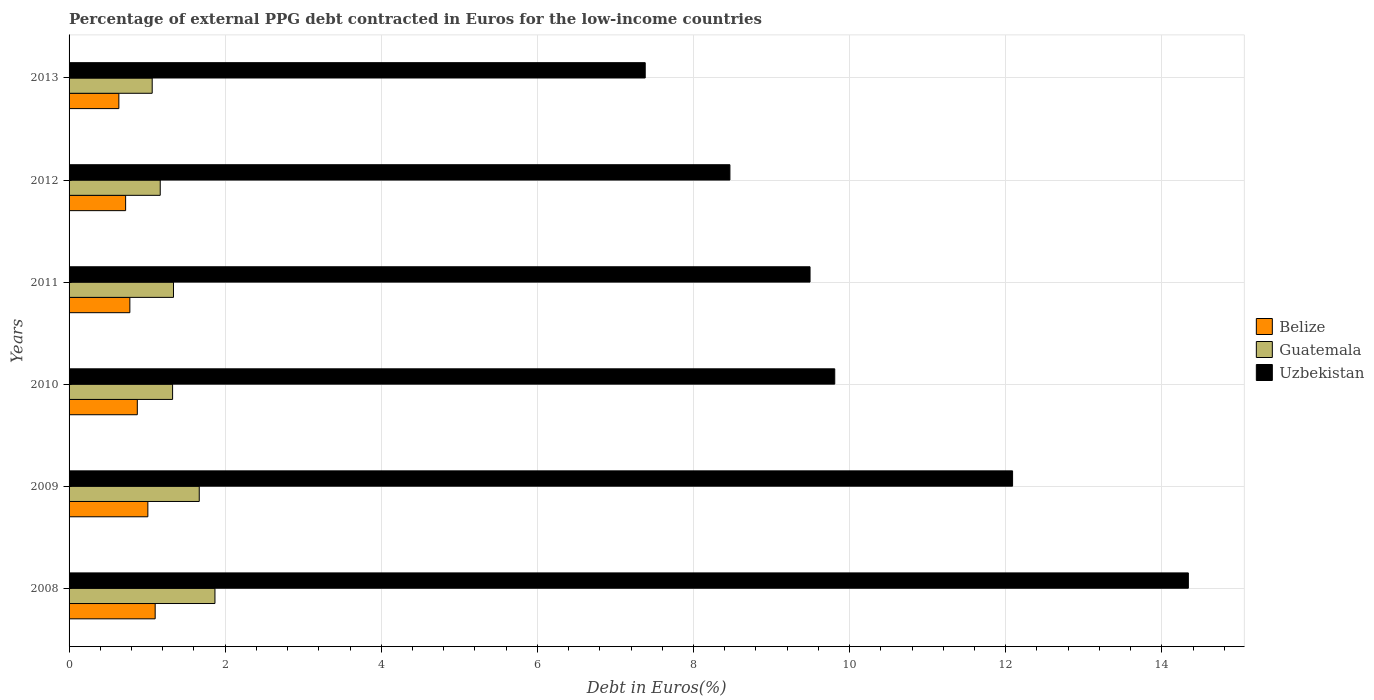How many different coloured bars are there?
Your answer should be compact. 3. Are the number of bars per tick equal to the number of legend labels?
Offer a terse response. Yes. Are the number of bars on each tick of the Y-axis equal?
Keep it short and to the point. Yes. How many bars are there on the 5th tick from the bottom?
Your answer should be compact. 3. In how many cases, is the number of bars for a given year not equal to the number of legend labels?
Ensure brevity in your answer.  0. What is the percentage of external PPG debt contracted in Euros in Guatemala in 2011?
Offer a very short reply. 1.34. Across all years, what is the maximum percentage of external PPG debt contracted in Euros in Guatemala?
Give a very brief answer. 1.87. Across all years, what is the minimum percentage of external PPG debt contracted in Euros in Guatemala?
Provide a short and direct response. 1.07. In which year was the percentage of external PPG debt contracted in Euros in Uzbekistan maximum?
Your answer should be very brief. 2008. In which year was the percentage of external PPG debt contracted in Euros in Belize minimum?
Your response must be concise. 2013. What is the total percentage of external PPG debt contracted in Euros in Belize in the graph?
Your response must be concise. 5.13. What is the difference between the percentage of external PPG debt contracted in Euros in Uzbekistan in 2011 and that in 2012?
Provide a succinct answer. 1.03. What is the difference between the percentage of external PPG debt contracted in Euros in Guatemala in 2008 and the percentage of external PPG debt contracted in Euros in Uzbekistan in 2013?
Offer a very short reply. -5.51. What is the average percentage of external PPG debt contracted in Euros in Belize per year?
Your answer should be very brief. 0.85. In the year 2012, what is the difference between the percentage of external PPG debt contracted in Euros in Guatemala and percentage of external PPG debt contracted in Euros in Belize?
Your answer should be compact. 0.44. What is the ratio of the percentage of external PPG debt contracted in Euros in Uzbekistan in 2012 to that in 2013?
Your answer should be compact. 1.15. What is the difference between the highest and the second highest percentage of external PPG debt contracted in Euros in Uzbekistan?
Offer a very short reply. 2.25. What is the difference between the highest and the lowest percentage of external PPG debt contracted in Euros in Guatemala?
Your answer should be compact. 0.8. What does the 1st bar from the top in 2008 represents?
Offer a terse response. Uzbekistan. What does the 2nd bar from the bottom in 2010 represents?
Your response must be concise. Guatemala. Is it the case that in every year, the sum of the percentage of external PPG debt contracted in Euros in Belize and percentage of external PPG debt contracted in Euros in Guatemala is greater than the percentage of external PPG debt contracted in Euros in Uzbekistan?
Give a very brief answer. No. How many bars are there?
Make the answer very short. 18. How many years are there in the graph?
Give a very brief answer. 6. What is the difference between two consecutive major ticks on the X-axis?
Provide a short and direct response. 2. How many legend labels are there?
Offer a terse response. 3. What is the title of the graph?
Provide a succinct answer. Percentage of external PPG debt contracted in Euros for the low-income countries. Does "Chile" appear as one of the legend labels in the graph?
Your response must be concise. No. What is the label or title of the X-axis?
Ensure brevity in your answer.  Debt in Euros(%). What is the label or title of the Y-axis?
Ensure brevity in your answer.  Years. What is the Debt in Euros(%) in Belize in 2008?
Your answer should be compact. 1.1. What is the Debt in Euros(%) in Guatemala in 2008?
Make the answer very short. 1.87. What is the Debt in Euros(%) in Uzbekistan in 2008?
Provide a succinct answer. 14.34. What is the Debt in Euros(%) in Belize in 2009?
Ensure brevity in your answer.  1.01. What is the Debt in Euros(%) of Guatemala in 2009?
Offer a terse response. 1.67. What is the Debt in Euros(%) of Uzbekistan in 2009?
Your answer should be very brief. 12.09. What is the Debt in Euros(%) in Belize in 2010?
Provide a succinct answer. 0.87. What is the Debt in Euros(%) in Guatemala in 2010?
Offer a very short reply. 1.33. What is the Debt in Euros(%) of Uzbekistan in 2010?
Give a very brief answer. 9.81. What is the Debt in Euros(%) in Belize in 2011?
Keep it short and to the point. 0.78. What is the Debt in Euros(%) in Guatemala in 2011?
Offer a terse response. 1.34. What is the Debt in Euros(%) in Uzbekistan in 2011?
Your response must be concise. 9.49. What is the Debt in Euros(%) in Belize in 2012?
Give a very brief answer. 0.72. What is the Debt in Euros(%) in Guatemala in 2012?
Your answer should be compact. 1.17. What is the Debt in Euros(%) in Uzbekistan in 2012?
Provide a short and direct response. 8.47. What is the Debt in Euros(%) of Belize in 2013?
Keep it short and to the point. 0.64. What is the Debt in Euros(%) of Guatemala in 2013?
Keep it short and to the point. 1.07. What is the Debt in Euros(%) in Uzbekistan in 2013?
Ensure brevity in your answer.  7.38. Across all years, what is the maximum Debt in Euros(%) in Belize?
Make the answer very short. 1.1. Across all years, what is the maximum Debt in Euros(%) in Guatemala?
Your answer should be very brief. 1.87. Across all years, what is the maximum Debt in Euros(%) in Uzbekistan?
Your answer should be very brief. 14.34. Across all years, what is the minimum Debt in Euros(%) of Belize?
Keep it short and to the point. 0.64. Across all years, what is the minimum Debt in Euros(%) in Guatemala?
Your answer should be compact. 1.07. Across all years, what is the minimum Debt in Euros(%) in Uzbekistan?
Your answer should be very brief. 7.38. What is the total Debt in Euros(%) of Belize in the graph?
Your answer should be very brief. 5.13. What is the total Debt in Euros(%) in Guatemala in the graph?
Your answer should be compact. 8.43. What is the total Debt in Euros(%) in Uzbekistan in the graph?
Your answer should be very brief. 61.58. What is the difference between the Debt in Euros(%) in Belize in 2008 and that in 2009?
Keep it short and to the point. 0.09. What is the difference between the Debt in Euros(%) of Guatemala in 2008 and that in 2009?
Provide a short and direct response. 0.2. What is the difference between the Debt in Euros(%) in Uzbekistan in 2008 and that in 2009?
Make the answer very short. 2.25. What is the difference between the Debt in Euros(%) of Belize in 2008 and that in 2010?
Give a very brief answer. 0.23. What is the difference between the Debt in Euros(%) of Guatemala in 2008 and that in 2010?
Your answer should be compact. 0.54. What is the difference between the Debt in Euros(%) of Uzbekistan in 2008 and that in 2010?
Your answer should be compact. 4.53. What is the difference between the Debt in Euros(%) in Belize in 2008 and that in 2011?
Provide a succinct answer. 0.32. What is the difference between the Debt in Euros(%) of Guatemala in 2008 and that in 2011?
Ensure brevity in your answer.  0.53. What is the difference between the Debt in Euros(%) of Uzbekistan in 2008 and that in 2011?
Ensure brevity in your answer.  4.85. What is the difference between the Debt in Euros(%) of Belize in 2008 and that in 2012?
Offer a very short reply. 0.38. What is the difference between the Debt in Euros(%) of Guatemala in 2008 and that in 2012?
Your response must be concise. 0.7. What is the difference between the Debt in Euros(%) of Uzbekistan in 2008 and that in 2012?
Offer a terse response. 5.87. What is the difference between the Debt in Euros(%) in Belize in 2008 and that in 2013?
Give a very brief answer. 0.47. What is the difference between the Debt in Euros(%) of Guatemala in 2008 and that in 2013?
Offer a very short reply. 0.8. What is the difference between the Debt in Euros(%) in Uzbekistan in 2008 and that in 2013?
Your answer should be compact. 6.96. What is the difference between the Debt in Euros(%) in Belize in 2009 and that in 2010?
Ensure brevity in your answer.  0.14. What is the difference between the Debt in Euros(%) of Guatemala in 2009 and that in 2010?
Your answer should be very brief. 0.34. What is the difference between the Debt in Euros(%) of Uzbekistan in 2009 and that in 2010?
Provide a short and direct response. 2.28. What is the difference between the Debt in Euros(%) of Belize in 2009 and that in 2011?
Your answer should be compact. 0.23. What is the difference between the Debt in Euros(%) of Guatemala in 2009 and that in 2011?
Provide a succinct answer. 0.33. What is the difference between the Debt in Euros(%) of Uzbekistan in 2009 and that in 2011?
Provide a short and direct response. 2.6. What is the difference between the Debt in Euros(%) of Belize in 2009 and that in 2012?
Provide a short and direct response. 0.28. What is the difference between the Debt in Euros(%) of Guatemala in 2009 and that in 2012?
Your answer should be very brief. 0.5. What is the difference between the Debt in Euros(%) of Uzbekistan in 2009 and that in 2012?
Provide a succinct answer. 3.62. What is the difference between the Debt in Euros(%) in Belize in 2009 and that in 2013?
Keep it short and to the point. 0.37. What is the difference between the Debt in Euros(%) in Guatemala in 2009 and that in 2013?
Ensure brevity in your answer.  0.6. What is the difference between the Debt in Euros(%) of Uzbekistan in 2009 and that in 2013?
Provide a short and direct response. 4.71. What is the difference between the Debt in Euros(%) of Belize in 2010 and that in 2011?
Offer a terse response. 0.1. What is the difference between the Debt in Euros(%) in Guatemala in 2010 and that in 2011?
Keep it short and to the point. -0.01. What is the difference between the Debt in Euros(%) of Uzbekistan in 2010 and that in 2011?
Give a very brief answer. 0.32. What is the difference between the Debt in Euros(%) of Belize in 2010 and that in 2012?
Your answer should be compact. 0.15. What is the difference between the Debt in Euros(%) of Guatemala in 2010 and that in 2012?
Ensure brevity in your answer.  0.16. What is the difference between the Debt in Euros(%) of Uzbekistan in 2010 and that in 2012?
Ensure brevity in your answer.  1.34. What is the difference between the Debt in Euros(%) of Belize in 2010 and that in 2013?
Offer a very short reply. 0.24. What is the difference between the Debt in Euros(%) of Guatemala in 2010 and that in 2013?
Ensure brevity in your answer.  0.26. What is the difference between the Debt in Euros(%) in Uzbekistan in 2010 and that in 2013?
Provide a short and direct response. 2.43. What is the difference between the Debt in Euros(%) in Belize in 2011 and that in 2012?
Provide a short and direct response. 0.05. What is the difference between the Debt in Euros(%) in Guatemala in 2011 and that in 2012?
Provide a short and direct response. 0.17. What is the difference between the Debt in Euros(%) of Uzbekistan in 2011 and that in 2012?
Your answer should be compact. 1.03. What is the difference between the Debt in Euros(%) of Belize in 2011 and that in 2013?
Your answer should be very brief. 0.14. What is the difference between the Debt in Euros(%) of Guatemala in 2011 and that in 2013?
Provide a succinct answer. 0.27. What is the difference between the Debt in Euros(%) in Uzbekistan in 2011 and that in 2013?
Give a very brief answer. 2.11. What is the difference between the Debt in Euros(%) in Belize in 2012 and that in 2013?
Provide a short and direct response. 0.09. What is the difference between the Debt in Euros(%) of Guatemala in 2012 and that in 2013?
Make the answer very short. 0.1. What is the difference between the Debt in Euros(%) of Uzbekistan in 2012 and that in 2013?
Make the answer very short. 1.09. What is the difference between the Debt in Euros(%) of Belize in 2008 and the Debt in Euros(%) of Guatemala in 2009?
Keep it short and to the point. -0.56. What is the difference between the Debt in Euros(%) of Belize in 2008 and the Debt in Euros(%) of Uzbekistan in 2009?
Offer a very short reply. -10.99. What is the difference between the Debt in Euros(%) of Guatemala in 2008 and the Debt in Euros(%) of Uzbekistan in 2009?
Ensure brevity in your answer.  -10.22. What is the difference between the Debt in Euros(%) of Belize in 2008 and the Debt in Euros(%) of Guatemala in 2010?
Keep it short and to the point. -0.22. What is the difference between the Debt in Euros(%) in Belize in 2008 and the Debt in Euros(%) in Uzbekistan in 2010?
Your response must be concise. -8.71. What is the difference between the Debt in Euros(%) in Guatemala in 2008 and the Debt in Euros(%) in Uzbekistan in 2010?
Your answer should be compact. -7.94. What is the difference between the Debt in Euros(%) of Belize in 2008 and the Debt in Euros(%) of Guatemala in 2011?
Offer a very short reply. -0.23. What is the difference between the Debt in Euros(%) of Belize in 2008 and the Debt in Euros(%) of Uzbekistan in 2011?
Provide a succinct answer. -8.39. What is the difference between the Debt in Euros(%) in Guatemala in 2008 and the Debt in Euros(%) in Uzbekistan in 2011?
Your answer should be very brief. -7.62. What is the difference between the Debt in Euros(%) of Belize in 2008 and the Debt in Euros(%) of Guatemala in 2012?
Your answer should be compact. -0.06. What is the difference between the Debt in Euros(%) of Belize in 2008 and the Debt in Euros(%) of Uzbekistan in 2012?
Offer a terse response. -7.36. What is the difference between the Debt in Euros(%) of Guatemala in 2008 and the Debt in Euros(%) of Uzbekistan in 2012?
Give a very brief answer. -6.6. What is the difference between the Debt in Euros(%) of Belize in 2008 and the Debt in Euros(%) of Guatemala in 2013?
Make the answer very short. 0.04. What is the difference between the Debt in Euros(%) of Belize in 2008 and the Debt in Euros(%) of Uzbekistan in 2013?
Keep it short and to the point. -6.28. What is the difference between the Debt in Euros(%) in Guatemala in 2008 and the Debt in Euros(%) in Uzbekistan in 2013?
Ensure brevity in your answer.  -5.51. What is the difference between the Debt in Euros(%) in Belize in 2009 and the Debt in Euros(%) in Guatemala in 2010?
Make the answer very short. -0.32. What is the difference between the Debt in Euros(%) in Belize in 2009 and the Debt in Euros(%) in Uzbekistan in 2010?
Your answer should be compact. -8.8. What is the difference between the Debt in Euros(%) in Guatemala in 2009 and the Debt in Euros(%) in Uzbekistan in 2010?
Your response must be concise. -8.14. What is the difference between the Debt in Euros(%) in Belize in 2009 and the Debt in Euros(%) in Guatemala in 2011?
Your response must be concise. -0.33. What is the difference between the Debt in Euros(%) of Belize in 2009 and the Debt in Euros(%) of Uzbekistan in 2011?
Your answer should be compact. -8.48. What is the difference between the Debt in Euros(%) of Guatemala in 2009 and the Debt in Euros(%) of Uzbekistan in 2011?
Provide a short and direct response. -7.83. What is the difference between the Debt in Euros(%) of Belize in 2009 and the Debt in Euros(%) of Guatemala in 2012?
Offer a very short reply. -0.16. What is the difference between the Debt in Euros(%) of Belize in 2009 and the Debt in Euros(%) of Uzbekistan in 2012?
Provide a succinct answer. -7.46. What is the difference between the Debt in Euros(%) of Guatemala in 2009 and the Debt in Euros(%) of Uzbekistan in 2012?
Make the answer very short. -6.8. What is the difference between the Debt in Euros(%) of Belize in 2009 and the Debt in Euros(%) of Guatemala in 2013?
Offer a very short reply. -0.06. What is the difference between the Debt in Euros(%) of Belize in 2009 and the Debt in Euros(%) of Uzbekistan in 2013?
Ensure brevity in your answer.  -6.37. What is the difference between the Debt in Euros(%) of Guatemala in 2009 and the Debt in Euros(%) of Uzbekistan in 2013?
Make the answer very short. -5.71. What is the difference between the Debt in Euros(%) in Belize in 2010 and the Debt in Euros(%) in Guatemala in 2011?
Make the answer very short. -0.46. What is the difference between the Debt in Euros(%) in Belize in 2010 and the Debt in Euros(%) in Uzbekistan in 2011?
Give a very brief answer. -8.62. What is the difference between the Debt in Euros(%) in Guatemala in 2010 and the Debt in Euros(%) in Uzbekistan in 2011?
Ensure brevity in your answer.  -8.17. What is the difference between the Debt in Euros(%) in Belize in 2010 and the Debt in Euros(%) in Guatemala in 2012?
Your answer should be compact. -0.29. What is the difference between the Debt in Euros(%) of Belize in 2010 and the Debt in Euros(%) of Uzbekistan in 2012?
Ensure brevity in your answer.  -7.59. What is the difference between the Debt in Euros(%) of Guatemala in 2010 and the Debt in Euros(%) of Uzbekistan in 2012?
Ensure brevity in your answer.  -7.14. What is the difference between the Debt in Euros(%) of Belize in 2010 and the Debt in Euros(%) of Guatemala in 2013?
Make the answer very short. -0.19. What is the difference between the Debt in Euros(%) of Belize in 2010 and the Debt in Euros(%) of Uzbekistan in 2013?
Give a very brief answer. -6.51. What is the difference between the Debt in Euros(%) of Guatemala in 2010 and the Debt in Euros(%) of Uzbekistan in 2013?
Your answer should be compact. -6.06. What is the difference between the Debt in Euros(%) in Belize in 2011 and the Debt in Euros(%) in Guatemala in 2012?
Your response must be concise. -0.39. What is the difference between the Debt in Euros(%) of Belize in 2011 and the Debt in Euros(%) of Uzbekistan in 2012?
Your answer should be very brief. -7.69. What is the difference between the Debt in Euros(%) in Guatemala in 2011 and the Debt in Euros(%) in Uzbekistan in 2012?
Offer a very short reply. -7.13. What is the difference between the Debt in Euros(%) in Belize in 2011 and the Debt in Euros(%) in Guatemala in 2013?
Ensure brevity in your answer.  -0.29. What is the difference between the Debt in Euros(%) in Belize in 2011 and the Debt in Euros(%) in Uzbekistan in 2013?
Ensure brevity in your answer.  -6.6. What is the difference between the Debt in Euros(%) in Guatemala in 2011 and the Debt in Euros(%) in Uzbekistan in 2013?
Give a very brief answer. -6.04. What is the difference between the Debt in Euros(%) of Belize in 2012 and the Debt in Euros(%) of Guatemala in 2013?
Offer a very short reply. -0.34. What is the difference between the Debt in Euros(%) in Belize in 2012 and the Debt in Euros(%) in Uzbekistan in 2013?
Keep it short and to the point. -6.66. What is the difference between the Debt in Euros(%) of Guatemala in 2012 and the Debt in Euros(%) of Uzbekistan in 2013?
Provide a succinct answer. -6.21. What is the average Debt in Euros(%) of Belize per year?
Offer a terse response. 0.85. What is the average Debt in Euros(%) of Guatemala per year?
Keep it short and to the point. 1.41. What is the average Debt in Euros(%) in Uzbekistan per year?
Offer a very short reply. 10.26. In the year 2008, what is the difference between the Debt in Euros(%) in Belize and Debt in Euros(%) in Guatemala?
Offer a very short reply. -0.77. In the year 2008, what is the difference between the Debt in Euros(%) in Belize and Debt in Euros(%) in Uzbekistan?
Ensure brevity in your answer.  -13.24. In the year 2008, what is the difference between the Debt in Euros(%) in Guatemala and Debt in Euros(%) in Uzbekistan?
Provide a succinct answer. -12.47. In the year 2009, what is the difference between the Debt in Euros(%) in Belize and Debt in Euros(%) in Guatemala?
Your response must be concise. -0.66. In the year 2009, what is the difference between the Debt in Euros(%) of Belize and Debt in Euros(%) of Uzbekistan?
Provide a short and direct response. -11.08. In the year 2009, what is the difference between the Debt in Euros(%) in Guatemala and Debt in Euros(%) in Uzbekistan?
Provide a short and direct response. -10.42. In the year 2010, what is the difference between the Debt in Euros(%) of Belize and Debt in Euros(%) of Guatemala?
Give a very brief answer. -0.45. In the year 2010, what is the difference between the Debt in Euros(%) of Belize and Debt in Euros(%) of Uzbekistan?
Make the answer very short. -8.94. In the year 2010, what is the difference between the Debt in Euros(%) in Guatemala and Debt in Euros(%) in Uzbekistan?
Provide a succinct answer. -8.48. In the year 2011, what is the difference between the Debt in Euros(%) of Belize and Debt in Euros(%) of Guatemala?
Your response must be concise. -0.56. In the year 2011, what is the difference between the Debt in Euros(%) in Belize and Debt in Euros(%) in Uzbekistan?
Your response must be concise. -8.71. In the year 2011, what is the difference between the Debt in Euros(%) of Guatemala and Debt in Euros(%) of Uzbekistan?
Offer a very short reply. -8.16. In the year 2012, what is the difference between the Debt in Euros(%) of Belize and Debt in Euros(%) of Guatemala?
Offer a very short reply. -0.44. In the year 2012, what is the difference between the Debt in Euros(%) in Belize and Debt in Euros(%) in Uzbekistan?
Make the answer very short. -7.74. In the year 2012, what is the difference between the Debt in Euros(%) in Guatemala and Debt in Euros(%) in Uzbekistan?
Your answer should be very brief. -7.3. In the year 2013, what is the difference between the Debt in Euros(%) of Belize and Debt in Euros(%) of Guatemala?
Offer a terse response. -0.43. In the year 2013, what is the difference between the Debt in Euros(%) in Belize and Debt in Euros(%) in Uzbekistan?
Provide a short and direct response. -6.74. In the year 2013, what is the difference between the Debt in Euros(%) of Guatemala and Debt in Euros(%) of Uzbekistan?
Ensure brevity in your answer.  -6.32. What is the ratio of the Debt in Euros(%) of Belize in 2008 to that in 2009?
Provide a succinct answer. 1.09. What is the ratio of the Debt in Euros(%) of Guatemala in 2008 to that in 2009?
Keep it short and to the point. 1.12. What is the ratio of the Debt in Euros(%) of Uzbekistan in 2008 to that in 2009?
Provide a succinct answer. 1.19. What is the ratio of the Debt in Euros(%) in Belize in 2008 to that in 2010?
Give a very brief answer. 1.26. What is the ratio of the Debt in Euros(%) of Guatemala in 2008 to that in 2010?
Provide a short and direct response. 1.41. What is the ratio of the Debt in Euros(%) in Uzbekistan in 2008 to that in 2010?
Keep it short and to the point. 1.46. What is the ratio of the Debt in Euros(%) in Belize in 2008 to that in 2011?
Offer a terse response. 1.42. What is the ratio of the Debt in Euros(%) of Guatemala in 2008 to that in 2011?
Provide a short and direct response. 1.4. What is the ratio of the Debt in Euros(%) in Uzbekistan in 2008 to that in 2011?
Give a very brief answer. 1.51. What is the ratio of the Debt in Euros(%) of Belize in 2008 to that in 2012?
Your answer should be compact. 1.52. What is the ratio of the Debt in Euros(%) in Guatemala in 2008 to that in 2012?
Your response must be concise. 1.6. What is the ratio of the Debt in Euros(%) in Uzbekistan in 2008 to that in 2012?
Offer a very short reply. 1.69. What is the ratio of the Debt in Euros(%) in Belize in 2008 to that in 2013?
Your answer should be very brief. 1.73. What is the ratio of the Debt in Euros(%) in Guatemala in 2008 to that in 2013?
Your answer should be compact. 1.75. What is the ratio of the Debt in Euros(%) in Uzbekistan in 2008 to that in 2013?
Keep it short and to the point. 1.94. What is the ratio of the Debt in Euros(%) in Belize in 2009 to that in 2010?
Keep it short and to the point. 1.15. What is the ratio of the Debt in Euros(%) in Guatemala in 2009 to that in 2010?
Offer a terse response. 1.26. What is the ratio of the Debt in Euros(%) of Uzbekistan in 2009 to that in 2010?
Your response must be concise. 1.23. What is the ratio of the Debt in Euros(%) in Belize in 2009 to that in 2011?
Give a very brief answer. 1.3. What is the ratio of the Debt in Euros(%) in Guatemala in 2009 to that in 2011?
Give a very brief answer. 1.25. What is the ratio of the Debt in Euros(%) of Uzbekistan in 2009 to that in 2011?
Ensure brevity in your answer.  1.27. What is the ratio of the Debt in Euros(%) of Belize in 2009 to that in 2012?
Make the answer very short. 1.39. What is the ratio of the Debt in Euros(%) in Guatemala in 2009 to that in 2012?
Give a very brief answer. 1.43. What is the ratio of the Debt in Euros(%) in Uzbekistan in 2009 to that in 2012?
Provide a succinct answer. 1.43. What is the ratio of the Debt in Euros(%) of Belize in 2009 to that in 2013?
Offer a terse response. 1.58. What is the ratio of the Debt in Euros(%) in Guatemala in 2009 to that in 2013?
Provide a short and direct response. 1.57. What is the ratio of the Debt in Euros(%) of Uzbekistan in 2009 to that in 2013?
Keep it short and to the point. 1.64. What is the ratio of the Debt in Euros(%) in Belize in 2010 to that in 2011?
Provide a succinct answer. 1.12. What is the ratio of the Debt in Euros(%) in Guatemala in 2010 to that in 2011?
Provide a succinct answer. 0.99. What is the ratio of the Debt in Euros(%) in Uzbekistan in 2010 to that in 2011?
Keep it short and to the point. 1.03. What is the ratio of the Debt in Euros(%) in Belize in 2010 to that in 2012?
Ensure brevity in your answer.  1.21. What is the ratio of the Debt in Euros(%) in Guatemala in 2010 to that in 2012?
Make the answer very short. 1.14. What is the ratio of the Debt in Euros(%) in Uzbekistan in 2010 to that in 2012?
Your answer should be very brief. 1.16. What is the ratio of the Debt in Euros(%) of Belize in 2010 to that in 2013?
Your answer should be very brief. 1.37. What is the ratio of the Debt in Euros(%) in Guatemala in 2010 to that in 2013?
Provide a succinct answer. 1.25. What is the ratio of the Debt in Euros(%) in Uzbekistan in 2010 to that in 2013?
Your response must be concise. 1.33. What is the ratio of the Debt in Euros(%) of Belize in 2011 to that in 2012?
Provide a succinct answer. 1.07. What is the ratio of the Debt in Euros(%) of Guatemala in 2011 to that in 2012?
Make the answer very short. 1.15. What is the ratio of the Debt in Euros(%) of Uzbekistan in 2011 to that in 2012?
Ensure brevity in your answer.  1.12. What is the ratio of the Debt in Euros(%) of Belize in 2011 to that in 2013?
Make the answer very short. 1.22. What is the ratio of the Debt in Euros(%) of Guatemala in 2011 to that in 2013?
Give a very brief answer. 1.26. What is the ratio of the Debt in Euros(%) in Uzbekistan in 2011 to that in 2013?
Make the answer very short. 1.29. What is the ratio of the Debt in Euros(%) of Belize in 2012 to that in 2013?
Make the answer very short. 1.14. What is the ratio of the Debt in Euros(%) of Guatemala in 2012 to that in 2013?
Offer a very short reply. 1.1. What is the ratio of the Debt in Euros(%) in Uzbekistan in 2012 to that in 2013?
Ensure brevity in your answer.  1.15. What is the difference between the highest and the second highest Debt in Euros(%) in Belize?
Offer a very short reply. 0.09. What is the difference between the highest and the second highest Debt in Euros(%) of Guatemala?
Provide a succinct answer. 0.2. What is the difference between the highest and the second highest Debt in Euros(%) in Uzbekistan?
Offer a very short reply. 2.25. What is the difference between the highest and the lowest Debt in Euros(%) in Belize?
Offer a very short reply. 0.47. What is the difference between the highest and the lowest Debt in Euros(%) in Guatemala?
Provide a short and direct response. 0.8. What is the difference between the highest and the lowest Debt in Euros(%) of Uzbekistan?
Your response must be concise. 6.96. 